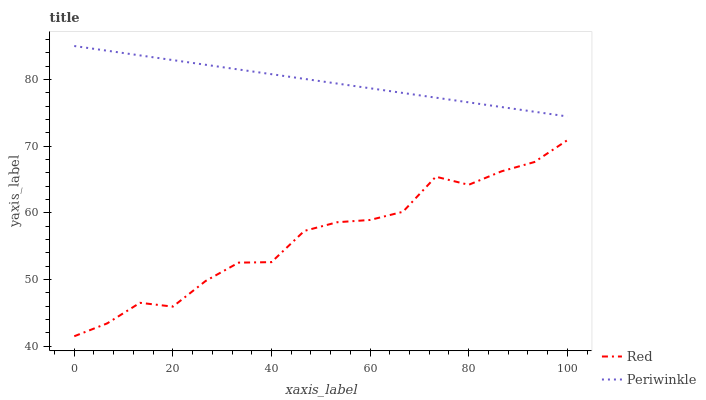Does Red have the minimum area under the curve?
Answer yes or no. Yes. Does Periwinkle have the maximum area under the curve?
Answer yes or no. Yes. Does Red have the maximum area under the curve?
Answer yes or no. No. Is Periwinkle the smoothest?
Answer yes or no. Yes. Is Red the roughest?
Answer yes or no. Yes. Is Red the smoothest?
Answer yes or no. No. Does Red have the highest value?
Answer yes or no. No. Is Red less than Periwinkle?
Answer yes or no. Yes. Is Periwinkle greater than Red?
Answer yes or no. Yes. Does Red intersect Periwinkle?
Answer yes or no. No. 